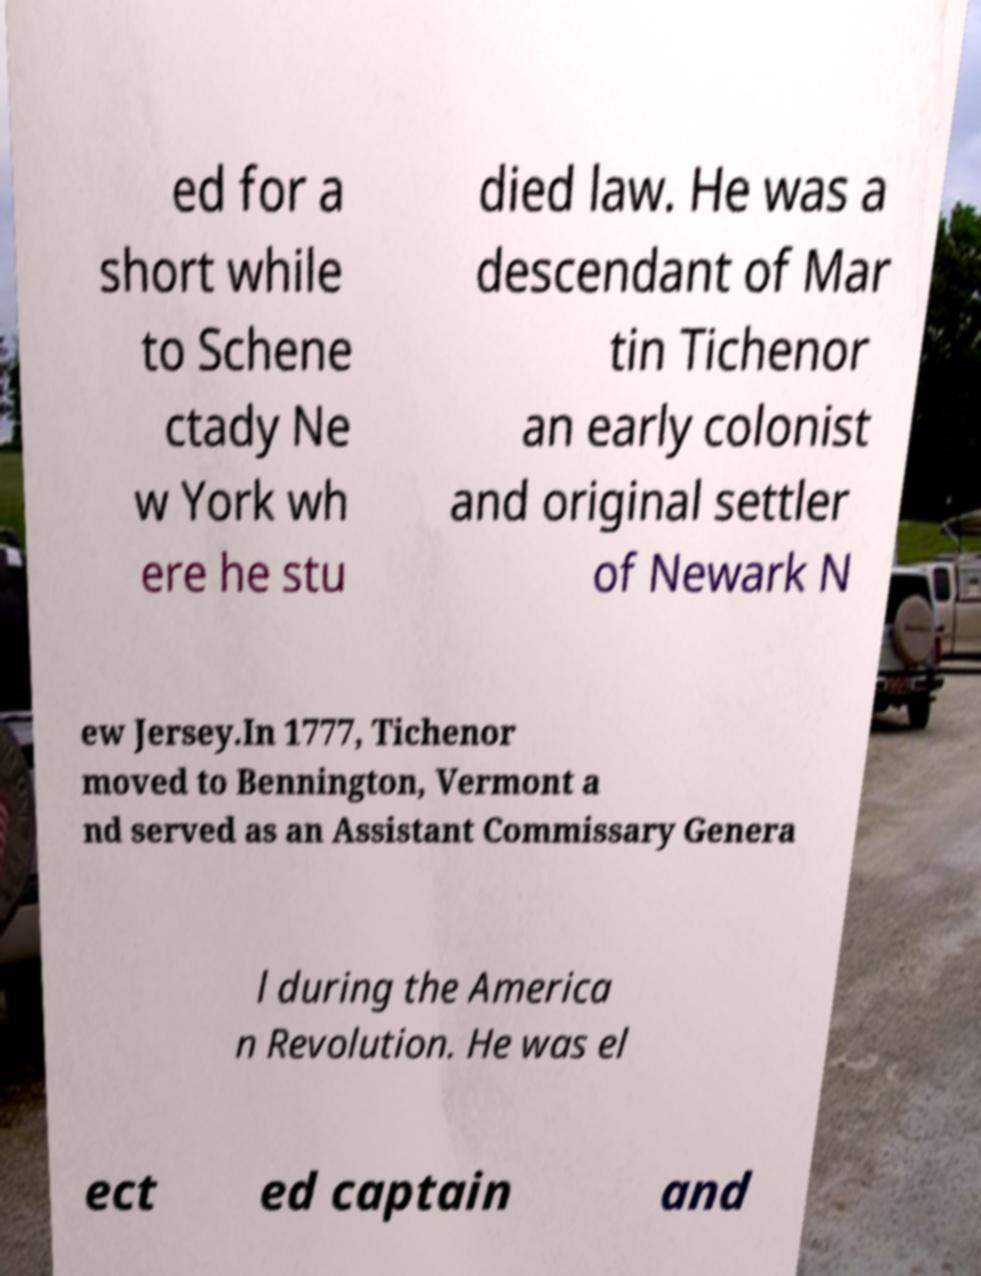I need the written content from this picture converted into text. Can you do that? ed for a short while to Schene ctady Ne w York wh ere he stu died law. He was a descendant of Mar tin Tichenor an early colonist and original settler of Newark N ew Jersey.In 1777, Tichenor moved to Bennington, Vermont a nd served as an Assistant Commissary Genera l during the America n Revolution. He was el ect ed captain and 